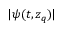Convert formula to latex. <formula><loc_0><loc_0><loc_500><loc_500>| \psi ( t , z _ { q } ) |</formula> 